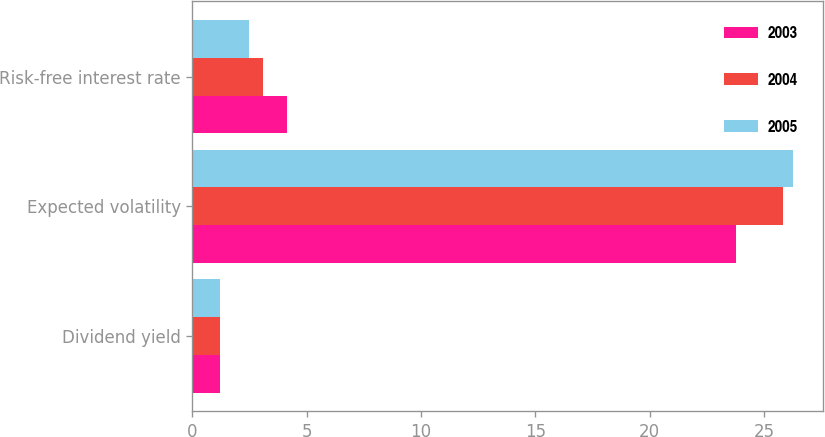<chart> <loc_0><loc_0><loc_500><loc_500><stacked_bar_chart><ecel><fcel>Dividend yield<fcel>Expected volatility<fcel>Risk-free interest rate<nl><fcel>2003<fcel>1.2<fcel>23.77<fcel>4.13<nl><fcel>2004<fcel>1.2<fcel>25.84<fcel>3.1<nl><fcel>2005<fcel>1.2<fcel>26.27<fcel>2.47<nl></chart> 